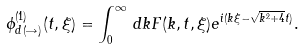<formula> <loc_0><loc_0><loc_500><loc_500>\phi ^ { ( 1 ) } _ { d \, ( \rightarrow ) } ( t , \xi ) = \int _ { 0 } ^ { \infty } \, d k F ( k , t , \xi ) e ^ { i ( k \xi - \sqrt { k ^ { 2 } + 4 } t ) } .</formula> 